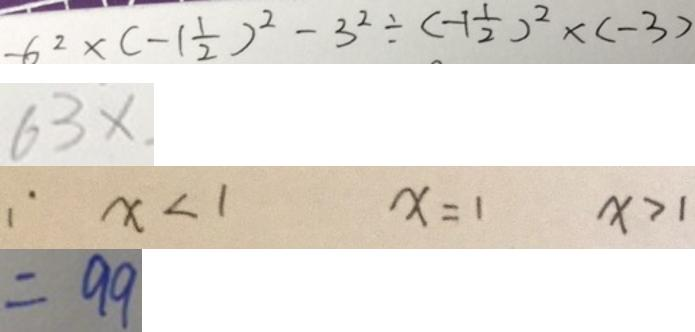Convert formula to latex. <formula><loc_0><loc_0><loc_500><loc_500>- 6 ^ { 2 } \times ( - 1 \frac { 1 } { 2 } ) ^ { 2 } - 3 ^ { 2 } \div ( - 1 \frac { 1 } { 2 } ) ^ { 2 } \times ( - 3 ) 
 6 3 x 
 \because x < 1 x = 1 x > 1 
 = 9 9</formula> 